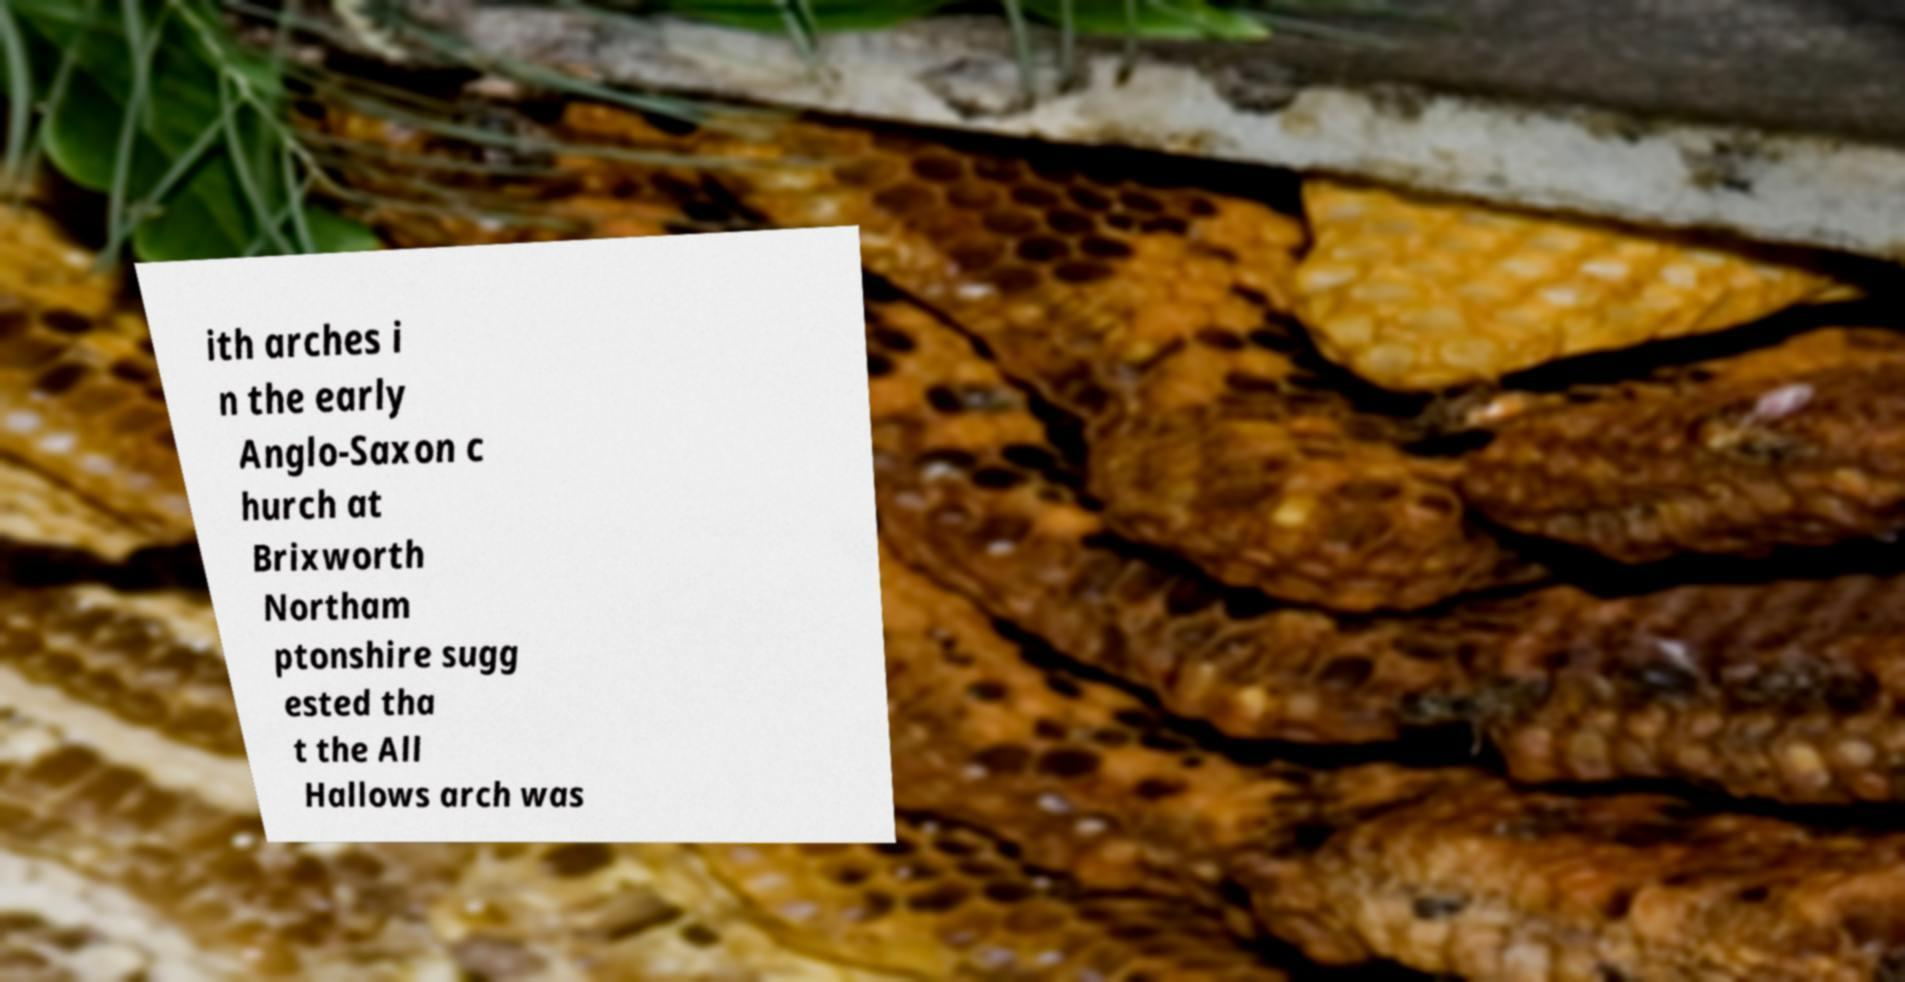Can you accurately transcribe the text from the provided image for me? ith arches i n the early Anglo-Saxon c hurch at Brixworth Northam ptonshire sugg ested tha t the All Hallows arch was 